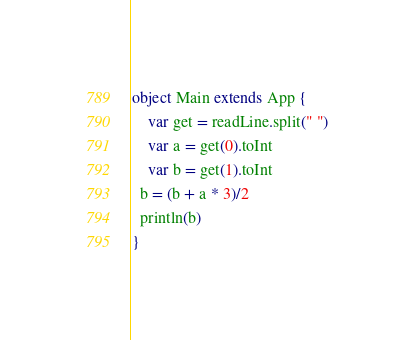Convert code to text. <code><loc_0><loc_0><loc_500><loc_500><_Scala_>object Main extends App {
    var get = readLine.split(" ")
    var a = get(0).toInt
    var b = get(1).toInt
  b = (b + a * 3)/2
  println(b)
}</code> 